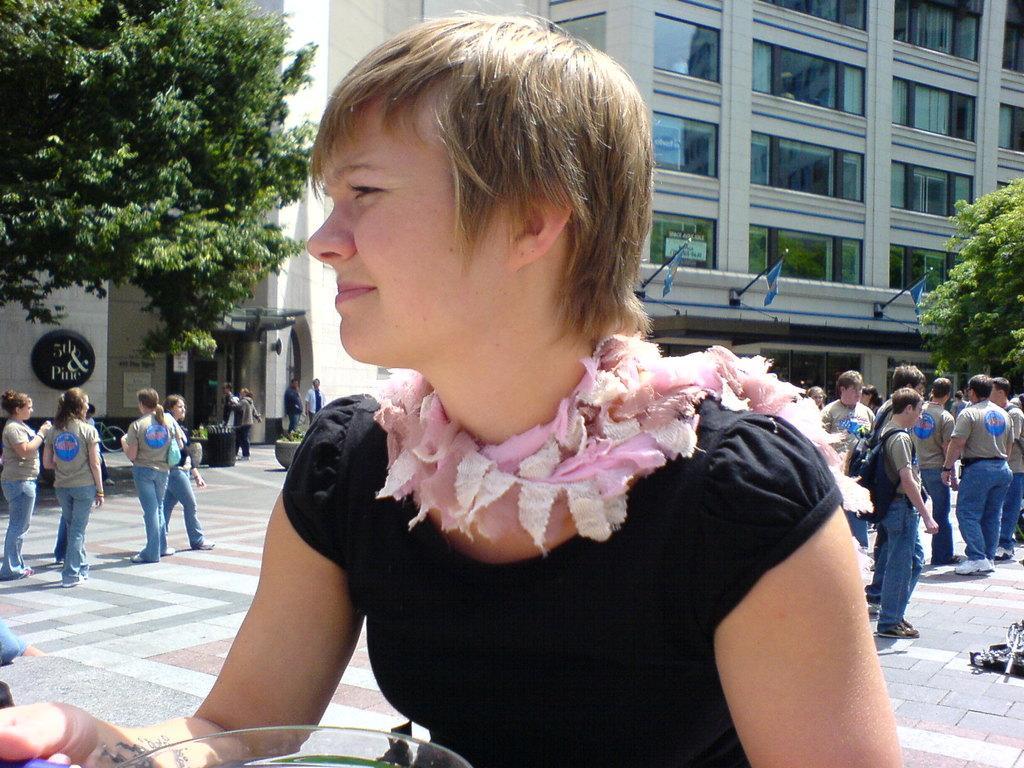In one or two sentences, can you explain what this image depicts? In this picture there is a woman sitting and holding the object. At the back there are group of people and there is a building and there are flags on the building and there are trees. On the left side of the image there are plants in the pots and there is a dustbin and there is a bicycle and there are boards on the wall. At the bottom there is a pavement. 